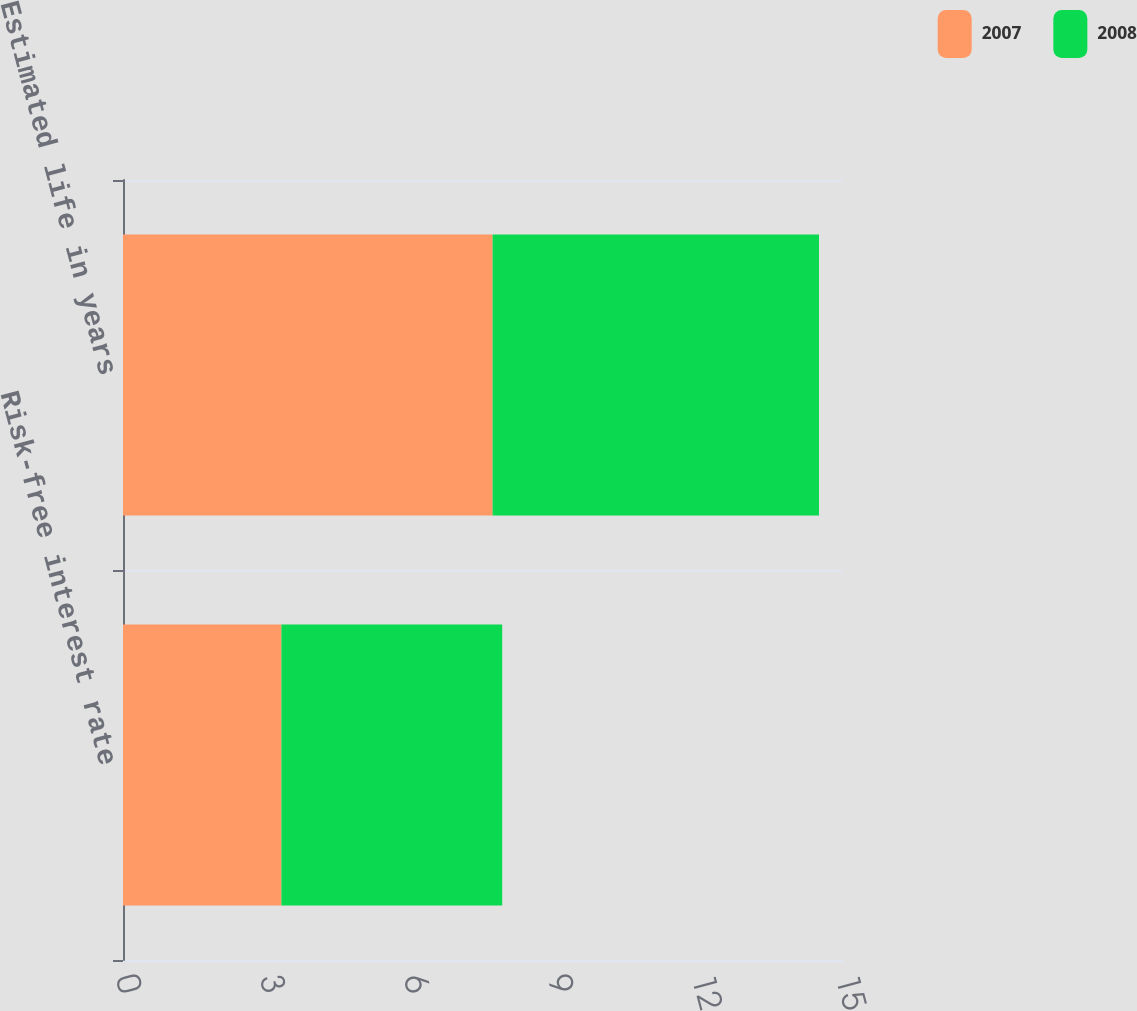Convert chart to OTSL. <chart><loc_0><loc_0><loc_500><loc_500><stacked_bar_chart><ecel><fcel>Risk-free interest rate<fcel>Estimated life in years<nl><fcel>2007<fcel>3.3<fcel>7.7<nl><fcel>2008<fcel>4.6<fcel>6.8<nl></chart> 